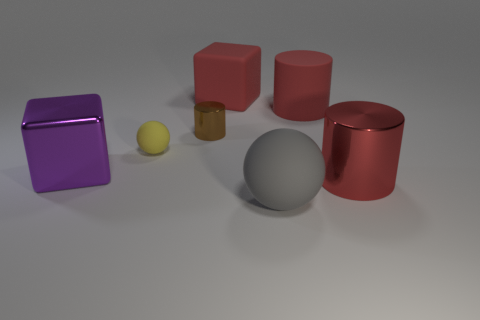Do the brown shiny object and the yellow matte ball have the same size?
Keep it short and to the point. Yes. There is a metal cylinder in front of the tiny yellow rubber ball; does it have the same color as the big rubber cylinder?
Keep it short and to the point. Yes. What number of small yellow matte objects are to the left of the tiny brown cylinder?
Provide a short and direct response. 1. Are there more red matte things than small matte things?
Your answer should be very brief. Yes. What shape is the object that is both to the left of the small cylinder and on the right side of the purple metallic block?
Make the answer very short. Sphere. Is there a tiny brown metallic cylinder?
Ensure brevity in your answer.  Yes. What is the material of the other object that is the same shape as the purple shiny thing?
Offer a very short reply. Rubber. The big gray object in front of the metal cylinder behind the metallic cylinder right of the gray rubber object is what shape?
Provide a succinct answer. Sphere. There is another cylinder that is the same color as the rubber cylinder; what is its material?
Your answer should be compact. Metal. How many other matte objects are the same shape as the yellow object?
Offer a very short reply. 1. 